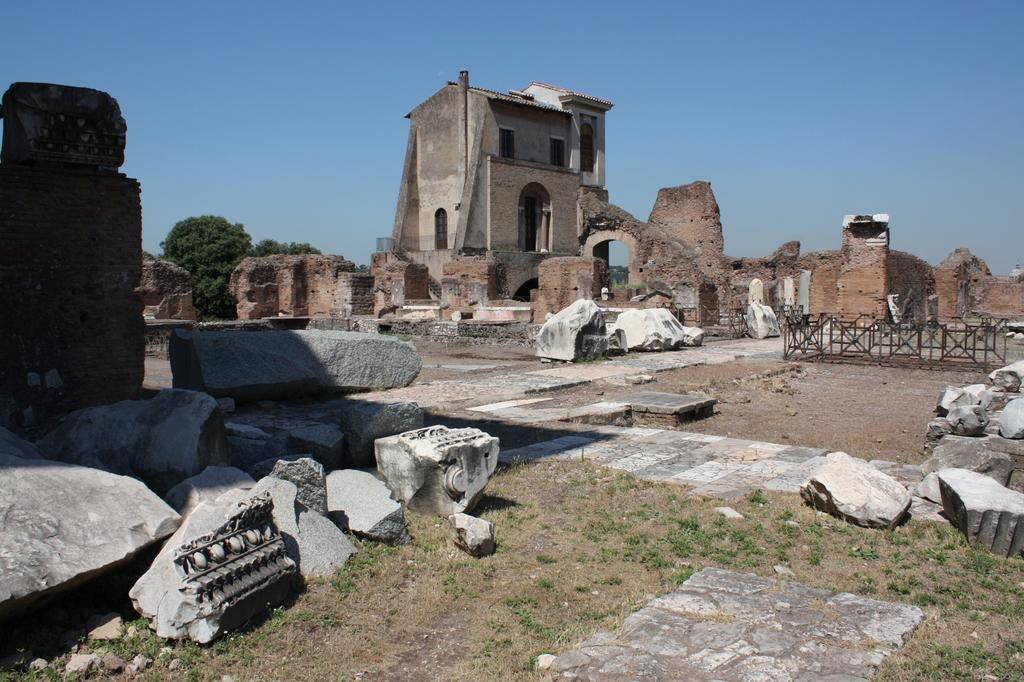What type of natural elements can be seen in the image? There are rocks and green grass in the image. What type of man-made structure is present in the image? There is an old house construction in the image. Where are the trees located in the image? The trees are on the left side of the image. What type of material is used for some objects in the image? There are metal objects in the image. What type of rings can be seen on the trees in the image? There are no rings visible on the trees in the image. Is there any smoke coming from the old house construction in the image? There is no smoke present in the image. 